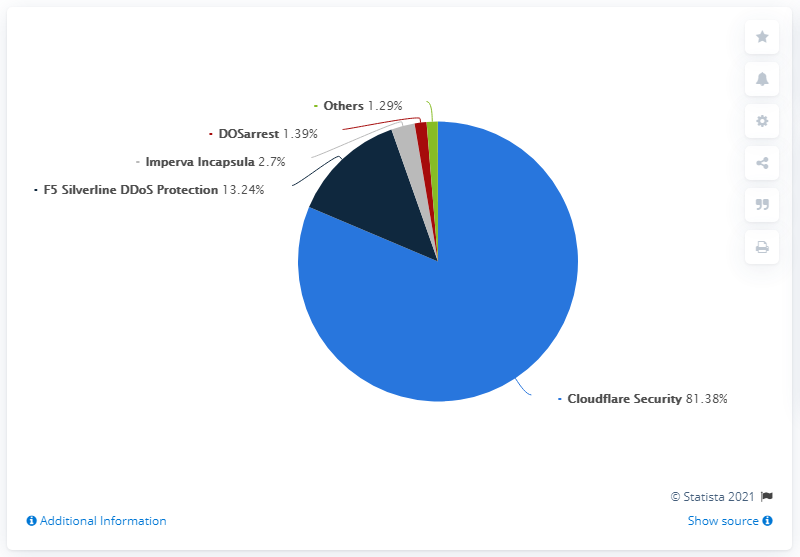List a handful of essential elements in this visual. According to data from April 2021, Cloudflare Security held approximately 81.38% of the market share in terms of security. The color of the largest segment is light blue. The sum of the two smallest segments is less than the gray segment. As of April 2021, Cloudflare Security had the greatest market share worldwide among all vendors. 